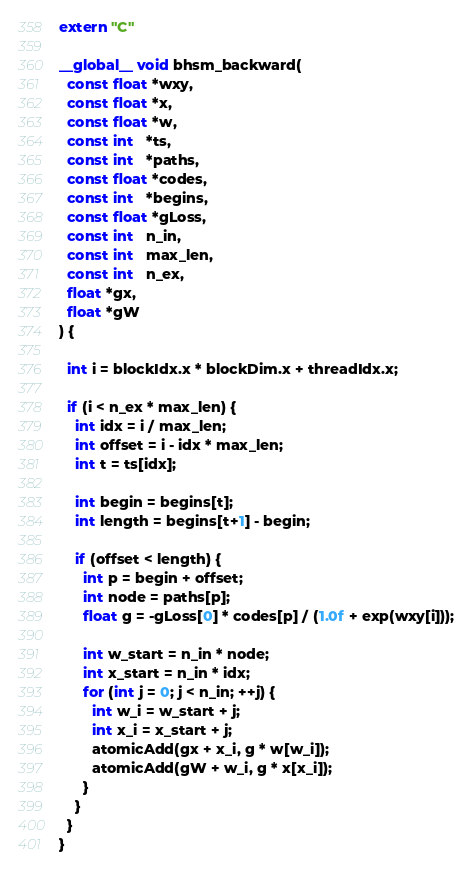<code> <loc_0><loc_0><loc_500><loc_500><_Cuda_>extern "C"

__global__ void bhsm_backward(
  const float *wxy,
  const float *x,
  const float *w,
  const int   *ts,
  const int   *paths,
  const float *codes,
  const int   *begins,
  const float *gLoss,
  const int   n_in,
  const int   max_len,
  const int   n_ex,
  float *gx,
  float *gW
) {

  int i = blockIdx.x * blockDim.x + threadIdx.x;

  if (i < n_ex * max_len) {
    int idx = i / max_len;
    int offset = i - idx * max_len;
    int t = ts[idx];

    int begin = begins[t];
    int length = begins[t+1] - begin;

    if (offset < length) {
      int p = begin + offset;
      int node = paths[p];
      float g = -gLoss[0] * codes[p] / (1.0f + exp(wxy[i]));

      int w_start = n_in * node;
      int x_start = n_in * idx;
      for (int j = 0; j < n_in; ++j) {
        int w_i = w_start + j;
        int x_i = x_start + j;
        atomicAdd(gx + x_i, g * w[w_i]);
        atomicAdd(gW + w_i, g * x[x_i]);
      }
    }
  }
}
</code> 